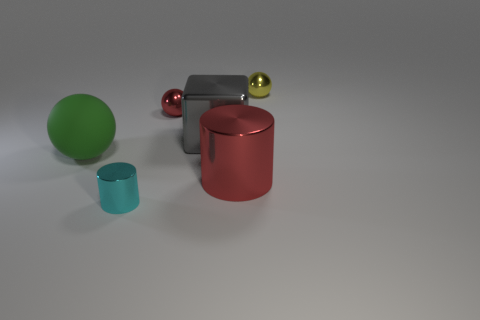Add 1 small cylinders. How many objects exist? 7 Subtract all cubes. How many objects are left? 5 Add 4 large gray metallic cubes. How many large gray metallic cubes are left? 5 Add 5 small purple matte balls. How many small purple matte balls exist? 5 Subtract 0 cyan cubes. How many objects are left? 6 Subtract all cyan metal cylinders. Subtract all tiny cyan objects. How many objects are left? 4 